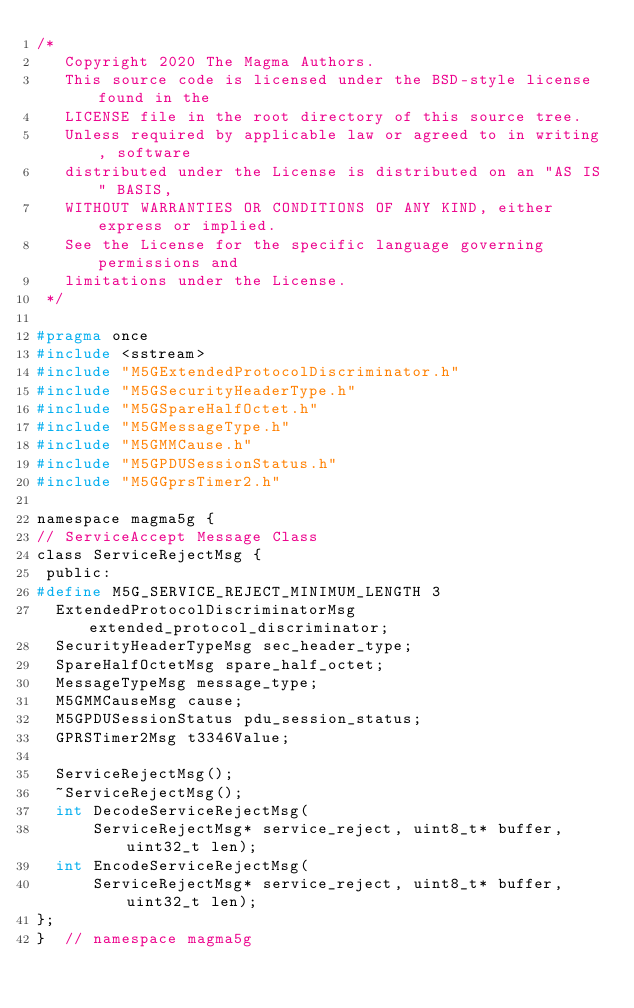Convert code to text. <code><loc_0><loc_0><loc_500><loc_500><_C_>/*
   Copyright 2020 The Magma Authors.
   This source code is licensed under the BSD-style license found in the
   LICENSE file in the root directory of this source tree.
   Unless required by applicable law or agreed to in writing, software
   distributed under the License is distributed on an "AS IS" BASIS,
   WITHOUT WARRANTIES OR CONDITIONS OF ANY KIND, either express or implied.
   See the License for the specific language governing permissions and
   limitations under the License.
 */

#pragma once
#include <sstream>
#include "M5GExtendedProtocolDiscriminator.h"
#include "M5GSecurityHeaderType.h"
#include "M5GSpareHalfOctet.h"
#include "M5GMessageType.h"
#include "M5GMMCause.h"
#include "M5GPDUSessionStatus.h"
#include "M5GGprsTimer2.h"

namespace magma5g {
// ServiceAccept Message Class
class ServiceRejectMsg {
 public:
#define M5G_SERVICE_REJECT_MINIMUM_LENGTH 3
  ExtendedProtocolDiscriminatorMsg extended_protocol_discriminator;
  SecurityHeaderTypeMsg sec_header_type;
  SpareHalfOctetMsg spare_half_octet;
  MessageTypeMsg message_type;
  M5GMMCauseMsg cause;
  M5GPDUSessionStatus pdu_session_status;
  GPRSTimer2Msg t3346Value;

  ServiceRejectMsg();
  ~ServiceRejectMsg();
  int DecodeServiceRejectMsg(
      ServiceRejectMsg* service_reject, uint8_t* buffer, uint32_t len);
  int EncodeServiceRejectMsg(
      ServiceRejectMsg* service_reject, uint8_t* buffer, uint32_t len);
};
}  // namespace magma5g
</code> 